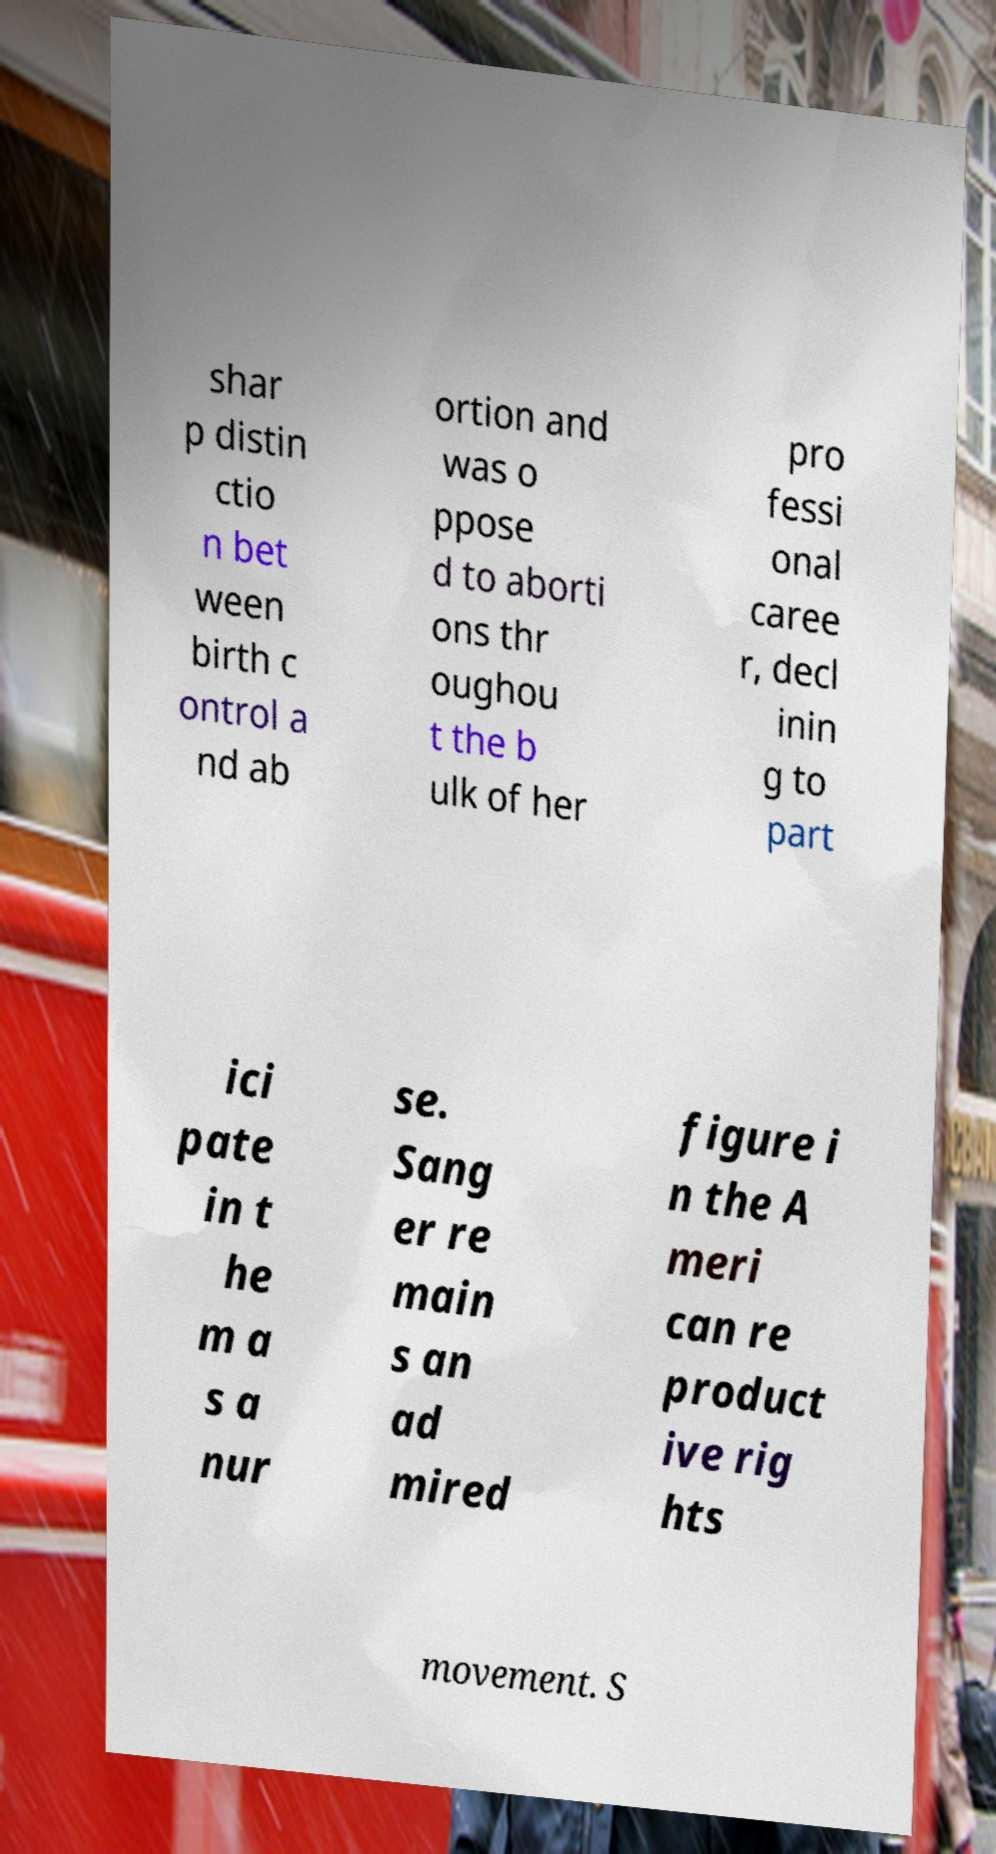For documentation purposes, I need the text within this image transcribed. Could you provide that? shar p distin ctio n bet ween birth c ontrol a nd ab ortion and was o ppose d to aborti ons thr oughou t the b ulk of her pro fessi onal caree r, decl inin g to part ici pate in t he m a s a nur se. Sang er re main s an ad mired figure i n the A meri can re product ive rig hts movement. S 